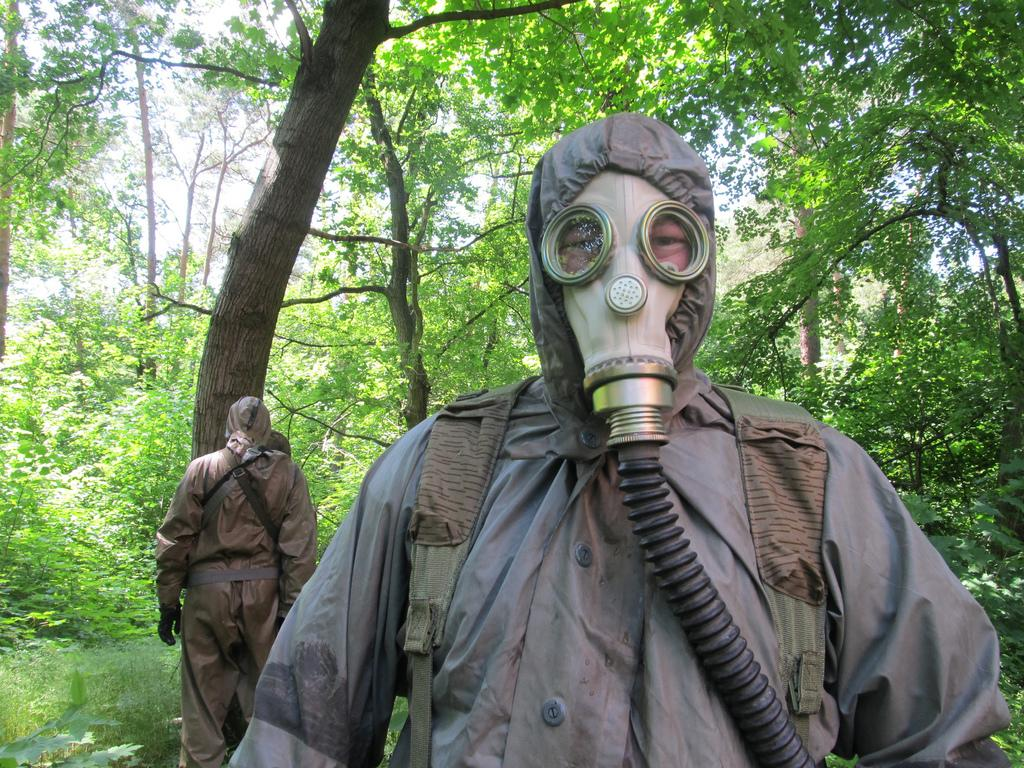How many people are in the image? There are people in the image. What are the people wearing? The people are wearing fully covered costumes and masks. What is unique about the masks the people are wearing? The masks have pipes attached to them. How does the beginner learn to open the door using the mask? There is no door present in the image, and the masks do not appear to be used for opening doors. 